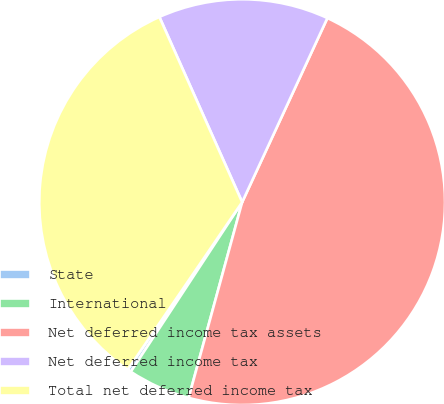<chart> <loc_0><loc_0><loc_500><loc_500><pie_chart><fcel>State<fcel>International<fcel>Net deferred income tax assets<fcel>Net deferred income tax<fcel>Total net deferred income tax<nl><fcel>0.29%<fcel>5.0%<fcel>47.35%<fcel>13.59%<fcel>33.77%<nl></chart> 